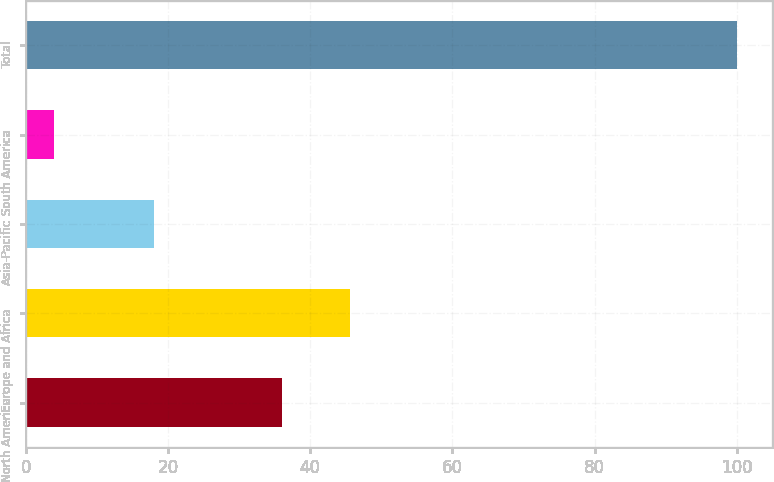Convert chart. <chart><loc_0><loc_0><loc_500><loc_500><bar_chart><fcel>North America<fcel>Europe and Africa<fcel>Asia-Pacific<fcel>South America<fcel>Total<nl><fcel>36<fcel>45.6<fcel>18<fcel>4<fcel>100<nl></chart> 